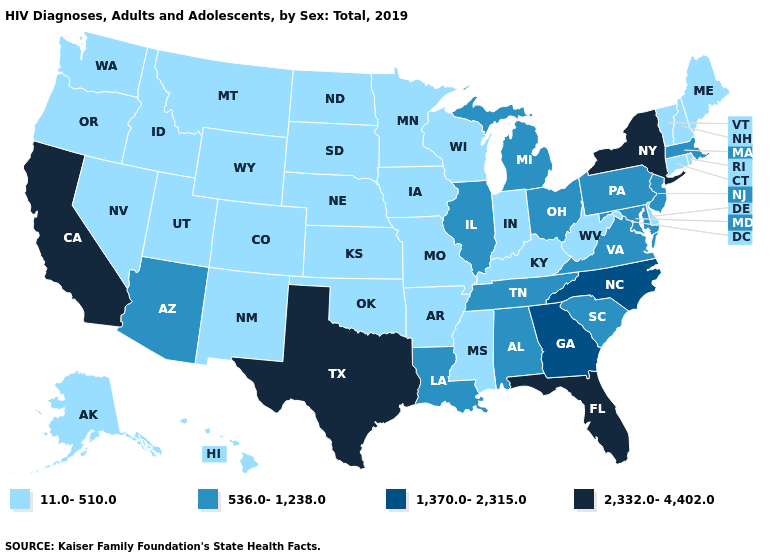Does Wyoming have the same value as Kansas?
Short answer required. Yes. What is the value of Minnesota?
Write a very short answer. 11.0-510.0. Is the legend a continuous bar?
Keep it brief. No. What is the lowest value in states that border California?
Be succinct. 11.0-510.0. Name the states that have a value in the range 1,370.0-2,315.0?
Quick response, please. Georgia, North Carolina. What is the lowest value in the Northeast?
Answer briefly. 11.0-510.0. Name the states that have a value in the range 2,332.0-4,402.0?
Be succinct. California, Florida, New York, Texas. Does Illinois have the highest value in the MidWest?
Short answer required. Yes. Name the states that have a value in the range 2,332.0-4,402.0?
Concise answer only. California, Florida, New York, Texas. Name the states that have a value in the range 1,370.0-2,315.0?
Keep it brief. Georgia, North Carolina. Among the states that border Louisiana , which have the highest value?
Quick response, please. Texas. Name the states that have a value in the range 11.0-510.0?
Write a very short answer. Alaska, Arkansas, Colorado, Connecticut, Delaware, Hawaii, Idaho, Indiana, Iowa, Kansas, Kentucky, Maine, Minnesota, Mississippi, Missouri, Montana, Nebraska, Nevada, New Hampshire, New Mexico, North Dakota, Oklahoma, Oregon, Rhode Island, South Dakota, Utah, Vermont, Washington, West Virginia, Wisconsin, Wyoming. Does Delaware have the lowest value in the South?
Short answer required. Yes. Among the states that border Michigan , does Ohio have the highest value?
Be succinct. Yes. Among the states that border California , which have the highest value?
Answer briefly. Arizona. 